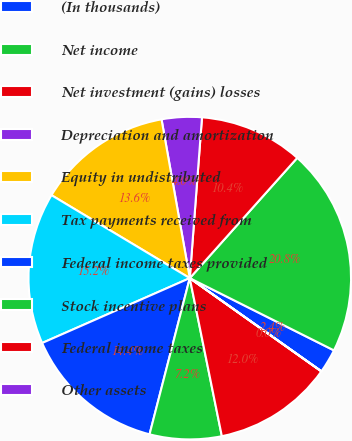Convert chart to OTSL. <chart><loc_0><loc_0><loc_500><loc_500><pie_chart><fcel>(In thousands)<fcel>Net income<fcel>Net investment (gains) losses<fcel>Depreciation and amortization<fcel>Equity in undistributed<fcel>Tax payments received from<fcel>Federal income taxes provided<fcel>Stock incentive plans<fcel>Federal income taxes<fcel>Other assets<nl><fcel>2.41%<fcel>20.79%<fcel>10.4%<fcel>4.01%<fcel>13.6%<fcel>15.19%<fcel>14.4%<fcel>7.2%<fcel>12.0%<fcel>0.01%<nl></chart> 